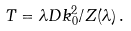Convert formula to latex. <formula><loc_0><loc_0><loc_500><loc_500>T = \lambda D k _ { 0 } ^ { 2 } / Z ( \lambda ) \, .</formula> 